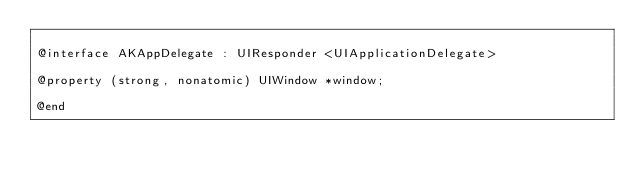<code> <loc_0><loc_0><loc_500><loc_500><_C_>
@interface AKAppDelegate : UIResponder <UIApplicationDelegate>

@property (strong, nonatomic) UIWindow *window;

@end
</code> 